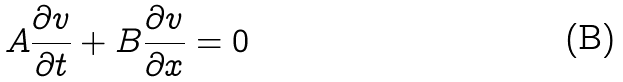<formula> <loc_0><loc_0><loc_500><loc_500>A \frac { \partial v } { \partial t } + B \frac { \partial v } { \partial x } = 0</formula> 